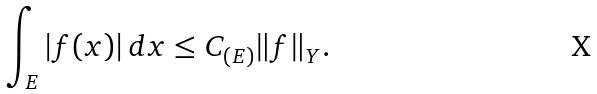<formula> <loc_0><loc_0><loc_500><loc_500>\int _ { E } | f ( x ) | \, d x \leq C _ { ( E ) } \| f \| _ { Y } .</formula> 